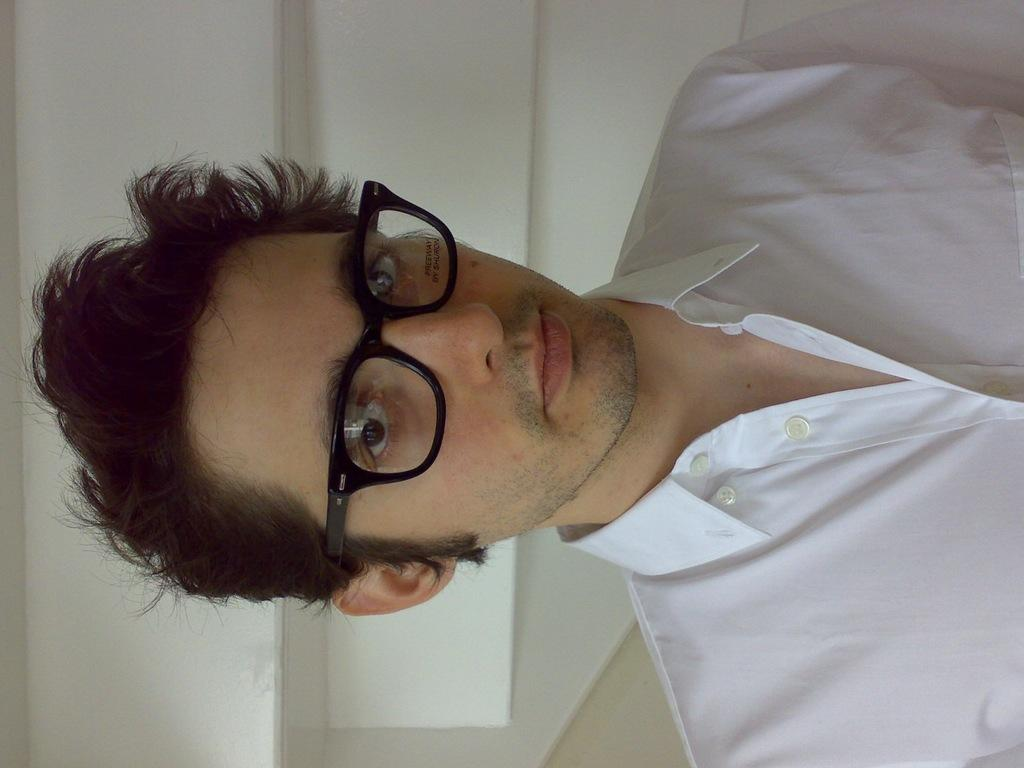What is the main subject of the image? There is a person in the image. Can you describe the person's appearance? The person is wearing glasses. What type of church can be seen in the background of the image? There is no church present in the image; it only features a person wearing glasses. 